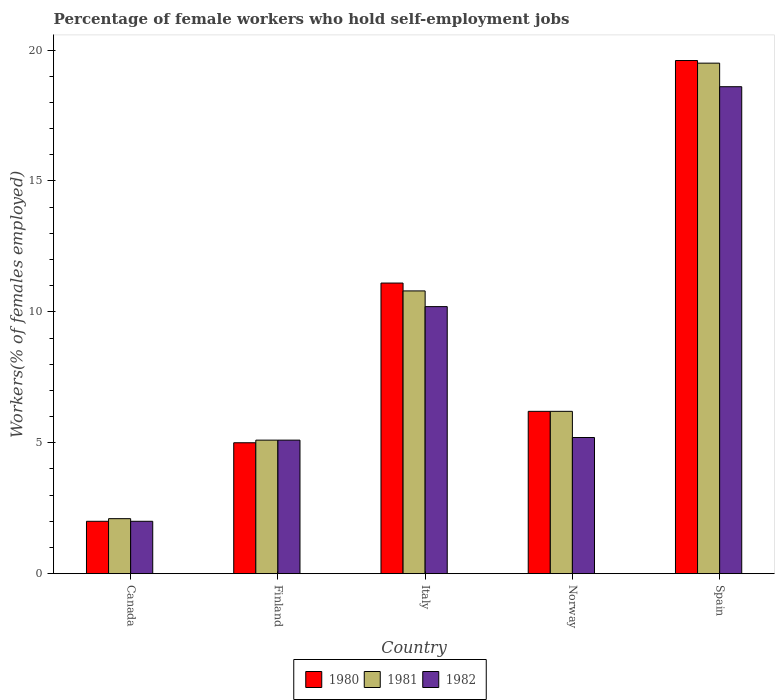How many different coloured bars are there?
Your answer should be very brief. 3. How many groups of bars are there?
Your answer should be compact. 5. Are the number of bars per tick equal to the number of legend labels?
Offer a terse response. Yes. How many bars are there on the 1st tick from the left?
Your answer should be compact. 3. What is the percentage of self-employed female workers in 1982 in Spain?
Offer a very short reply. 18.6. Across all countries, what is the maximum percentage of self-employed female workers in 1982?
Your answer should be compact. 18.6. Across all countries, what is the minimum percentage of self-employed female workers in 1981?
Make the answer very short. 2.1. What is the total percentage of self-employed female workers in 1981 in the graph?
Offer a terse response. 43.7. What is the difference between the percentage of self-employed female workers in 1982 in Italy and that in Spain?
Offer a very short reply. -8.4. What is the difference between the percentage of self-employed female workers in 1980 in Italy and the percentage of self-employed female workers in 1982 in Finland?
Ensure brevity in your answer.  6. What is the average percentage of self-employed female workers in 1980 per country?
Your answer should be very brief. 8.78. What is the difference between the percentage of self-employed female workers of/in 1981 and percentage of self-employed female workers of/in 1982 in Canada?
Your response must be concise. 0.1. In how many countries, is the percentage of self-employed female workers in 1981 greater than 7 %?
Provide a short and direct response. 2. What is the ratio of the percentage of self-employed female workers in 1982 in Canada to that in Finland?
Ensure brevity in your answer.  0.39. What is the difference between the highest and the second highest percentage of self-employed female workers in 1980?
Your answer should be compact. -8.5. What is the difference between the highest and the lowest percentage of self-employed female workers in 1981?
Offer a terse response. 17.4. Is it the case that in every country, the sum of the percentage of self-employed female workers in 1982 and percentage of self-employed female workers in 1981 is greater than the percentage of self-employed female workers in 1980?
Provide a short and direct response. Yes. How many countries are there in the graph?
Provide a succinct answer. 5. What is the difference between two consecutive major ticks on the Y-axis?
Ensure brevity in your answer.  5. What is the title of the graph?
Your answer should be compact. Percentage of female workers who hold self-employment jobs. What is the label or title of the Y-axis?
Your answer should be compact. Workers(% of females employed). What is the Workers(% of females employed) of 1980 in Canada?
Provide a short and direct response. 2. What is the Workers(% of females employed) in 1981 in Canada?
Ensure brevity in your answer.  2.1. What is the Workers(% of females employed) in 1981 in Finland?
Your answer should be very brief. 5.1. What is the Workers(% of females employed) in 1982 in Finland?
Your response must be concise. 5.1. What is the Workers(% of females employed) in 1980 in Italy?
Provide a short and direct response. 11.1. What is the Workers(% of females employed) in 1981 in Italy?
Make the answer very short. 10.8. What is the Workers(% of females employed) in 1982 in Italy?
Provide a succinct answer. 10.2. What is the Workers(% of females employed) of 1980 in Norway?
Provide a short and direct response. 6.2. What is the Workers(% of females employed) of 1981 in Norway?
Your response must be concise. 6.2. What is the Workers(% of females employed) of 1982 in Norway?
Offer a terse response. 5.2. What is the Workers(% of females employed) of 1980 in Spain?
Your answer should be very brief. 19.6. What is the Workers(% of females employed) of 1982 in Spain?
Keep it short and to the point. 18.6. Across all countries, what is the maximum Workers(% of females employed) in 1980?
Give a very brief answer. 19.6. Across all countries, what is the maximum Workers(% of females employed) of 1982?
Offer a very short reply. 18.6. Across all countries, what is the minimum Workers(% of females employed) of 1981?
Ensure brevity in your answer.  2.1. What is the total Workers(% of females employed) of 1980 in the graph?
Make the answer very short. 43.9. What is the total Workers(% of females employed) of 1981 in the graph?
Make the answer very short. 43.7. What is the total Workers(% of females employed) in 1982 in the graph?
Your answer should be very brief. 41.1. What is the difference between the Workers(% of females employed) in 1980 in Canada and that in Finland?
Make the answer very short. -3. What is the difference between the Workers(% of females employed) of 1981 in Canada and that in Finland?
Provide a succinct answer. -3. What is the difference between the Workers(% of females employed) in 1982 in Canada and that in Finland?
Make the answer very short. -3.1. What is the difference between the Workers(% of females employed) of 1980 in Canada and that in Italy?
Your response must be concise. -9.1. What is the difference between the Workers(% of females employed) in 1982 in Canada and that in Norway?
Your response must be concise. -3.2. What is the difference between the Workers(% of females employed) of 1980 in Canada and that in Spain?
Your answer should be very brief. -17.6. What is the difference between the Workers(% of females employed) of 1981 in Canada and that in Spain?
Provide a short and direct response. -17.4. What is the difference between the Workers(% of females employed) of 1982 in Canada and that in Spain?
Ensure brevity in your answer.  -16.6. What is the difference between the Workers(% of females employed) in 1980 in Finland and that in Italy?
Keep it short and to the point. -6.1. What is the difference between the Workers(% of females employed) of 1981 in Finland and that in Italy?
Keep it short and to the point. -5.7. What is the difference between the Workers(% of females employed) of 1982 in Finland and that in Italy?
Offer a terse response. -5.1. What is the difference between the Workers(% of females employed) in 1980 in Finland and that in Norway?
Give a very brief answer. -1.2. What is the difference between the Workers(% of females employed) of 1981 in Finland and that in Norway?
Give a very brief answer. -1.1. What is the difference between the Workers(% of females employed) in 1980 in Finland and that in Spain?
Give a very brief answer. -14.6. What is the difference between the Workers(% of females employed) in 1981 in Finland and that in Spain?
Keep it short and to the point. -14.4. What is the difference between the Workers(% of females employed) of 1982 in Finland and that in Spain?
Offer a very short reply. -13.5. What is the difference between the Workers(% of females employed) of 1982 in Italy and that in Norway?
Provide a succinct answer. 5. What is the difference between the Workers(% of females employed) in 1981 in Italy and that in Spain?
Your response must be concise. -8.7. What is the difference between the Workers(% of females employed) in 1981 in Norway and that in Spain?
Provide a short and direct response. -13.3. What is the difference between the Workers(% of females employed) in 1980 in Canada and the Workers(% of females employed) in 1981 in Finland?
Your answer should be compact. -3.1. What is the difference between the Workers(% of females employed) in 1981 in Canada and the Workers(% of females employed) in 1982 in Finland?
Your answer should be compact. -3. What is the difference between the Workers(% of females employed) in 1981 in Canada and the Workers(% of females employed) in 1982 in Italy?
Make the answer very short. -8.1. What is the difference between the Workers(% of females employed) of 1980 in Canada and the Workers(% of females employed) of 1981 in Norway?
Keep it short and to the point. -4.2. What is the difference between the Workers(% of females employed) in 1980 in Canada and the Workers(% of females employed) in 1982 in Norway?
Offer a terse response. -3.2. What is the difference between the Workers(% of females employed) in 1980 in Canada and the Workers(% of females employed) in 1981 in Spain?
Keep it short and to the point. -17.5. What is the difference between the Workers(% of females employed) of 1980 in Canada and the Workers(% of females employed) of 1982 in Spain?
Your answer should be very brief. -16.6. What is the difference between the Workers(% of females employed) in 1981 in Canada and the Workers(% of females employed) in 1982 in Spain?
Offer a terse response. -16.5. What is the difference between the Workers(% of females employed) of 1980 in Finland and the Workers(% of females employed) of 1982 in Italy?
Provide a succinct answer. -5.2. What is the difference between the Workers(% of females employed) of 1980 in Finland and the Workers(% of females employed) of 1982 in Norway?
Make the answer very short. -0.2. What is the difference between the Workers(% of females employed) of 1981 in Finland and the Workers(% of females employed) of 1982 in Spain?
Provide a succinct answer. -13.5. What is the difference between the Workers(% of females employed) in 1980 in Italy and the Workers(% of females employed) in 1981 in Norway?
Your response must be concise. 4.9. What is the difference between the Workers(% of females employed) of 1980 in Italy and the Workers(% of females employed) of 1982 in Norway?
Your answer should be very brief. 5.9. What is the difference between the Workers(% of females employed) in 1980 in Italy and the Workers(% of females employed) in 1982 in Spain?
Offer a very short reply. -7.5. What is the difference between the Workers(% of females employed) of 1981 in Italy and the Workers(% of females employed) of 1982 in Spain?
Offer a terse response. -7.8. What is the difference between the Workers(% of females employed) in 1980 in Norway and the Workers(% of females employed) in 1981 in Spain?
Ensure brevity in your answer.  -13.3. What is the average Workers(% of females employed) in 1980 per country?
Your response must be concise. 8.78. What is the average Workers(% of females employed) in 1981 per country?
Give a very brief answer. 8.74. What is the average Workers(% of females employed) in 1982 per country?
Your answer should be very brief. 8.22. What is the difference between the Workers(% of females employed) in 1980 and Workers(% of females employed) in 1982 in Finland?
Your response must be concise. -0.1. What is the difference between the Workers(% of females employed) in 1980 and Workers(% of females employed) in 1981 in Italy?
Your answer should be compact. 0.3. What is the difference between the Workers(% of females employed) in 1981 and Workers(% of females employed) in 1982 in Norway?
Your response must be concise. 1. What is the difference between the Workers(% of females employed) of 1980 and Workers(% of females employed) of 1981 in Spain?
Provide a short and direct response. 0.1. What is the ratio of the Workers(% of females employed) in 1981 in Canada to that in Finland?
Your answer should be very brief. 0.41. What is the ratio of the Workers(% of females employed) of 1982 in Canada to that in Finland?
Your response must be concise. 0.39. What is the ratio of the Workers(% of females employed) of 1980 in Canada to that in Italy?
Your answer should be compact. 0.18. What is the ratio of the Workers(% of females employed) of 1981 in Canada to that in Italy?
Give a very brief answer. 0.19. What is the ratio of the Workers(% of females employed) in 1982 in Canada to that in Italy?
Provide a short and direct response. 0.2. What is the ratio of the Workers(% of females employed) in 1980 in Canada to that in Norway?
Your answer should be very brief. 0.32. What is the ratio of the Workers(% of females employed) in 1981 in Canada to that in Norway?
Provide a succinct answer. 0.34. What is the ratio of the Workers(% of females employed) of 1982 in Canada to that in Norway?
Your response must be concise. 0.38. What is the ratio of the Workers(% of females employed) in 1980 in Canada to that in Spain?
Keep it short and to the point. 0.1. What is the ratio of the Workers(% of females employed) in 1981 in Canada to that in Spain?
Offer a very short reply. 0.11. What is the ratio of the Workers(% of females employed) in 1982 in Canada to that in Spain?
Your answer should be compact. 0.11. What is the ratio of the Workers(% of females employed) of 1980 in Finland to that in Italy?
Provide a short and direct response. 0.45. What is the ratio of the Workers(% of females employed) of 1981 in Finland to that in Italy?
Provide a succinct answer. 0.47. What is the ratio of the Workers(% of females employed) of 1980 in Finland to that in Norway?
Provide a short and direct response. 0.81. What is the ratio of the Workers(% of females employed) of 1981 in Finland to that in Norway?
Keep it short and to the point. 0.82. What is the ratio of the Workers(% of females employed) in 1982 in Finland to that in Norway?
Your answer should be very brief. 0.98. What is the ratio of the Workers(% of females employed) in 1980 in Finland to that in Spain?
Your answer should be compact. 0.26. What is the ratio of the Workers(% of females employed) of 1981 in Finland to that in Spain?
Your answer should be compact. 0.26. What is the ratio of the Workers(% of females employed) in 1982 in Finland to that in Spain?
Offer a very short reply. 0.27. What is the ratio of the Workers(% of females employed) in 1980 in Italy to that in Norway?
Your answer should be compact. 1.79. What is the ratio of the Workers(% of females employed) of 1981 in Italy to that in Norway?
Make the answer very short. 1.74. What is the ratio of the Workers(% of females employed) in 1982 in Italy to that in Norway?
Keep it short and to the point. 1.96. What is the ratio of the Workers(% of females employed) of 1980 in Italy to that in Spain?
Give a very brief answer. 0.57. What is the ratio of the Workers(% of females employed) in 1981 in Italy to that in Spain?
Your answer should be compact. 0.55. What is the ratio of the Workers(% of females employed) in 1982 in Italy to that in Spain?
Make the answer very short. 0.55. What is the ratio of the Workers(% of females employed) in 1980 in Norway to that in Spain?
Offer a terse response. 0.32. What is the ratio of the Workers(% of females employed) of 1981 in Norway to that in Spain?
Provide a succinct answer. 0.32. What is the ratio of the Workers(% of females employed) of 1982 in Norway to that in Spain?
Give a very brief answer. 0.28. What is the difference between the highest and the second highest Workers(% of females employed) of 1981?
Keep it short and to the point. 8.7. What is the difference between the highest and the lowest Workers(% of females employed) in 1980?
Your response must be concise. 17.6. What is the difference between the highest and the lowest Workers(% of females employed) of 1981?
Offer a very short reply. 17.4. 